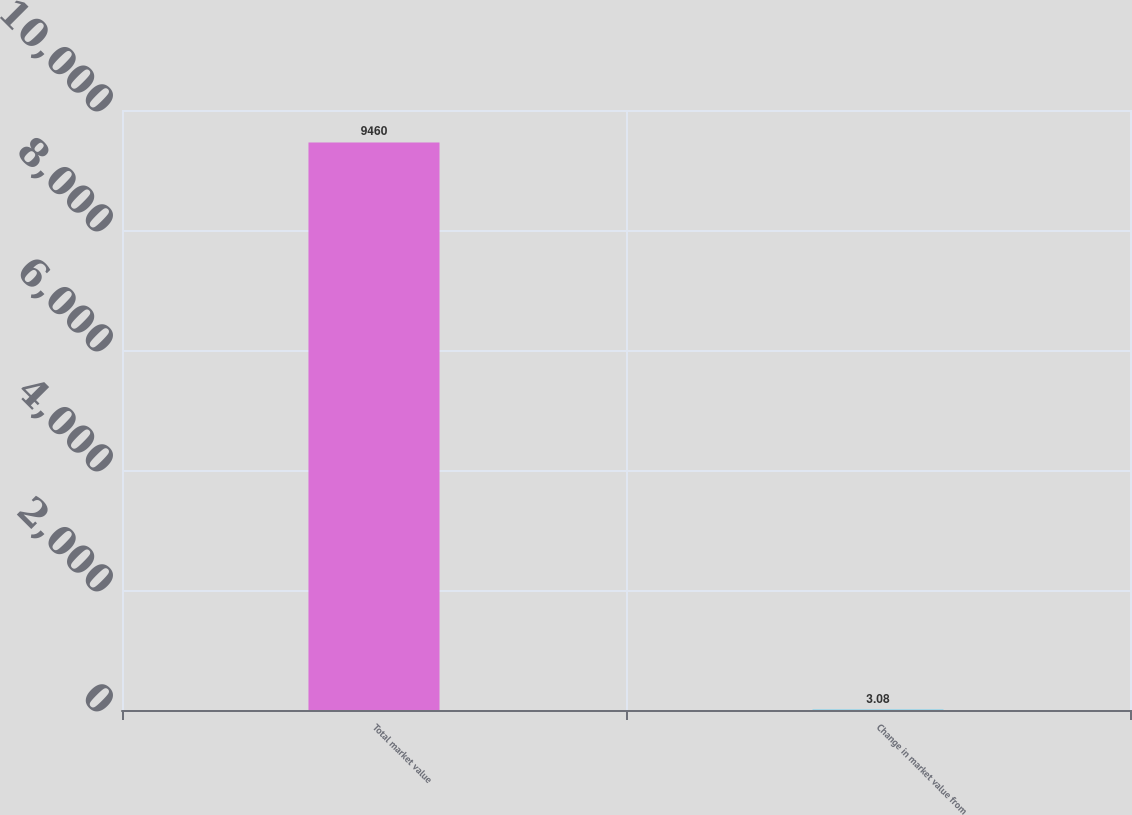Convert chart. <chart><loc_0><loc_0><loc_500><loc_500><bar_chart><fcel>Total market value<fcel>Change in market value from<nl><fcel>9460<fcel>3.08<nl></chart> 